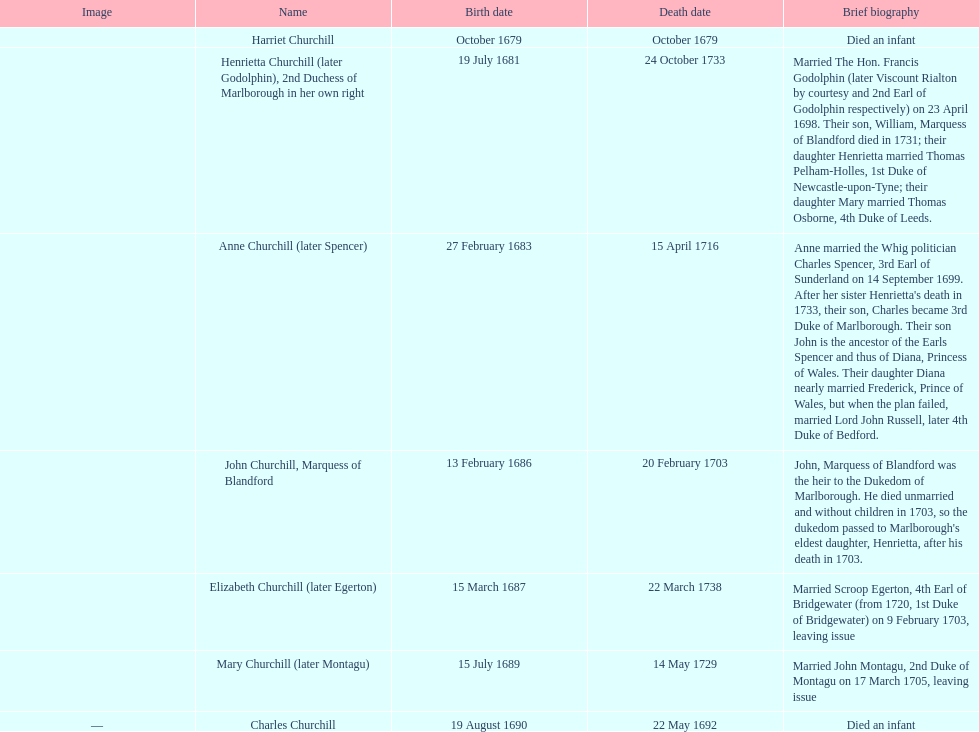After 1675, what is the overall count of children born? 7. 